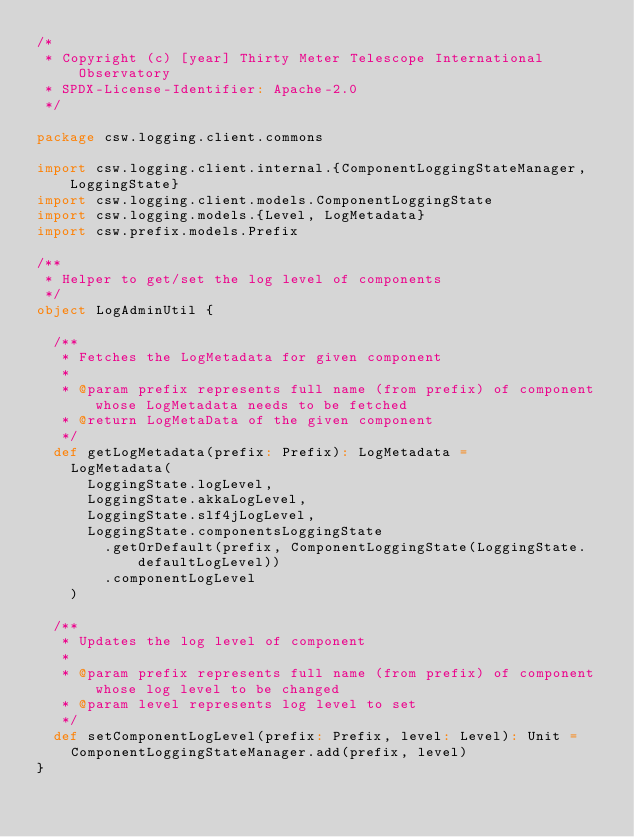<code> <loc_0><loc_0><loc_500><loc_500><_Scala_>/*
 * Copyright (c) [year] Thirty Meter Telescope International Observatory
 * SPDX-License-Identifier: Apache-2.0
 */

package csw.logging.client.commons

import csw.logging.client.internal.{ComponentLoggingStateManager, LoggingState}
import csw.logging.client.models.ComponentLoggingState
import csw.logging.models.{Level, LogMetadata}
import csw.prefix.models.Prefix

/**
 * Helper to get/set the log level of components
 */
object LogAdminUtil {

  /**
   * Fetches the LogMetadata for given component
   *
   * @param prefix represents full name (from prefix) of component whose LogMetadata needs to be fetched
   * @return LogMetaData of the given component
   */
  def getLogMetadata(prefix: Prefix): LogMetadata =
    LogMetadata(
      LoggingState.logLevel,
      LoggingState.akkaLogLevel,
      LoggingState.slf4jLogLevel,
      LoggingState.componentsLoggingState
        .getOrDefault(prefix, ComponentLoggingState(LoggingState.defaultLogLevel))
        .componentLogLevel
    )

  /**
   * Updates the log level of component
   *
   * @param prefix represents full name (from prefix) of component whose log level to be changed
   * @param level represents log level to set
   */
  def setComponentLogLevel(prefix: Prefix, level: Level): Unit =
    ComponentLoggingStateManager.add(prefix, level)
}
</code> 